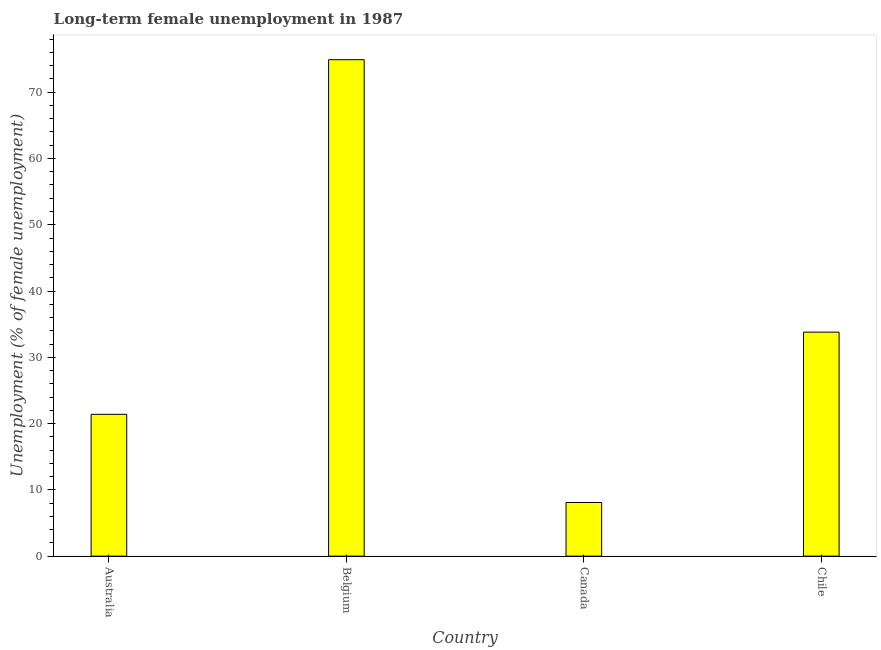Does the graph contain any zero values?
Your answer should be very brief. No. What is the title of the graph?
Offer a terse response. Long-term female unemployment in 1987. What is the label or title of the Y-axis?
Offer a very short reply. Unemployment (% of female unemployment). What is the long-term female unemployment in Belgium?
Ensure brevity in your answer.  74.9. Across all countries, what is the maximum long-term female unemployment?
Provide a succinct answer. 74.9. Across all countries, what is the minimum long-term female unemployment?
Ensure brevity in your answer.  8.1. In which country was the long-term female unemployment minimum?
Ensure brevity in your answer.  Canada. What is the sum of the long-term female unemployment?
Ensure brevity in your answer.  138.2. What is the average long-term female unemployment per country?
Give a very brief answer. 34.55. What is the median long-term female unemployment?
Provide a succinct answer. 27.6. In how many countries, is the long-term female unemployment greater than 2 %?
Offer a terse response. 4. What is the ratio of the long-term female unemployment in Belgium to that in Chile?
Offer a very short reply. 2.22. What is the difference between the highest and the second highest long-term female unemployment?
Ensure brevity in your answer.  41.1. What is the difference between the highest and the lowest long-term female unemployment?
Give a very brief answer. 66.8. In how many countries, is the long-term female unemployment greater than the average long-term female unemployment taken over all countries?
Offer a very short reply. 1. How many countries are there in the graph?
Give a very brief answer. 4. What is the Unemployment (% of female unemployment) in Australia?
Ensure brevity in your answer.  21.4. What is the Unemployment (% of female unemployment) of Belgium?
Your answer should be very brief. 74.9. What is the Unemployment (% of female unemployment) of Canada?
Ensure brevity in your answer.  8.1. What is the Unemployment (% of female unemployment) in Chile?
Your response must be concise. 33.8. What is the difference between the Unemployment (% of female unemployment) in Australia and Belgium?
Your answer should be very brief. -53.5. What is the difference between the Unemployment (% of female unemployment) in Belgium and Canada?
Provide a short and direct response. 66.8. What is the difference between the Unemployment (% of female unemployment) in Belgium and Chile?
Your response must be concise. 41.1. What is the difference between the Unemployment (% of female unemployment) in Canada and Chile?
Make the answer very short. -25.7. What is the ratio of the Unemployment (% of female unemployment) in Australia to that in Belgium?
Give a very brief answer. 0.29. What is the ratio of the Unemployment (% of female unemployment) in Australia to that in Canada?
Make the answer very short. 2.64. What is the ratio of the Unemployment (% of female unemployment) in Australia to that in Chile?
Provide a succinct answer. 0.63. What is the ratio of the Unemployment (% of female unemployment) in Belgium to that in Canada?
Provide a short and direct response. 9.25. What is the ratio of the Unemployment (% of female unemployment) in Belgium to that in Chile?
Your response must be concise. 2.22. What is the ratio of the Unemployment (% of female unemployment) in Canada to that in Chile?
Offer a terse response. 0.24. 